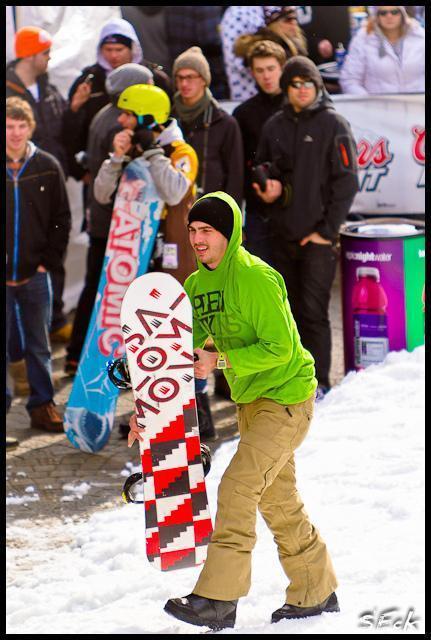How many people are there?
Give a very brief answer. 11. How many snowboards are in the picture?
Give a very brief answer. 2. 